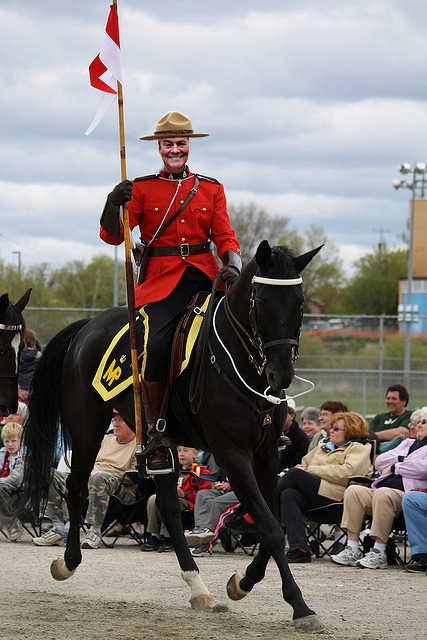Identify the text contained in this image. NP 